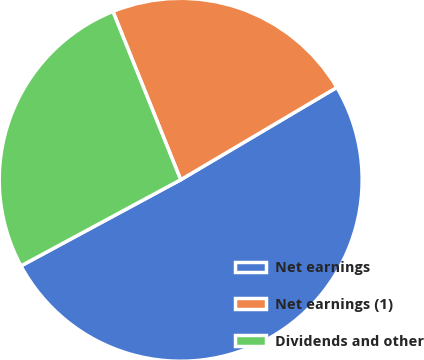Convert chart. <chart><loc_0><loc_0><loc_500><loc_500><pie_chart><fcel>Net earnings<fcel>Net earnings (1)<fcel>Dividends and other<nl><fcel>50.63%<fcel>22.59%<fcel>26.78%<nl></chart> 